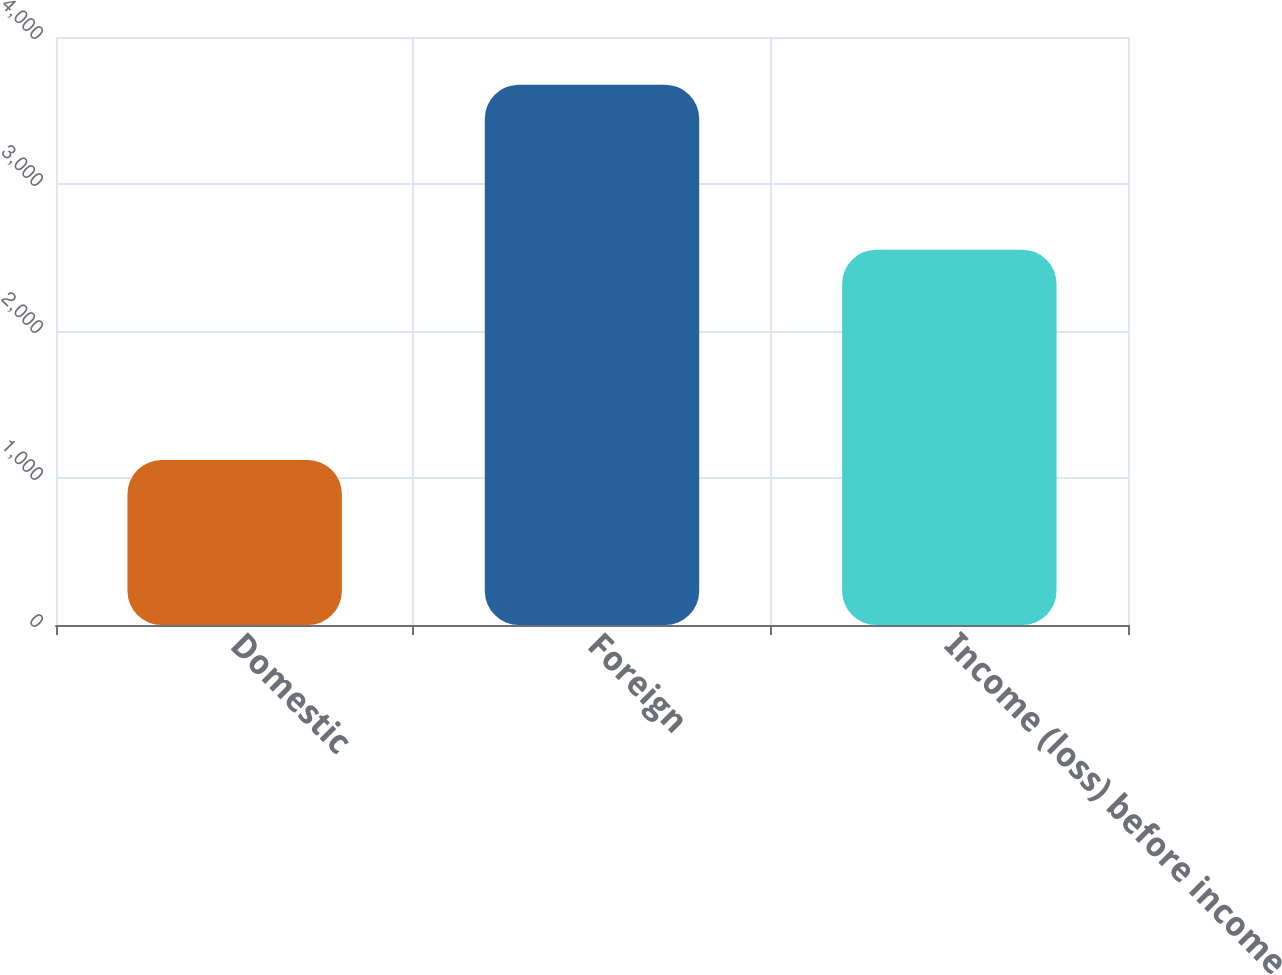Convert chart to OTSL. <chart><loc_0><loc_0><loc_500><loc_500><bar_chart><fcel>Domestic<fcel>Foreign<fcel>Income (loss) before income<nl><fcel>1122<fcel>3675<fcel>2553<nl></chart> 